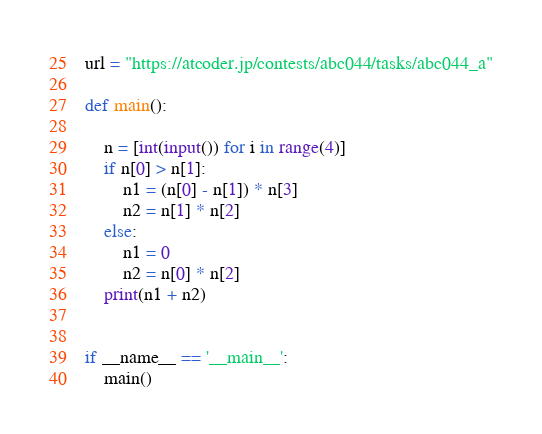Convert code to text. <code><loc_0><loc_0><loc_500><loc_500><_Python_>url = "https://atcoder.jp/contests/abc044/tasks/abc044_a"

def main():

    n = [int(input()) for i in range(4)]
    if n[0] > n[1]:
        n1 = (n[0] - n[1]) * n[3]
        n2 = n[1] * n[2]
    else:
        n1 = 0
        n2 = n[0] * n[2]
    print(n1 + n2)


if __name__ == '__main__':
    main()


</code> 